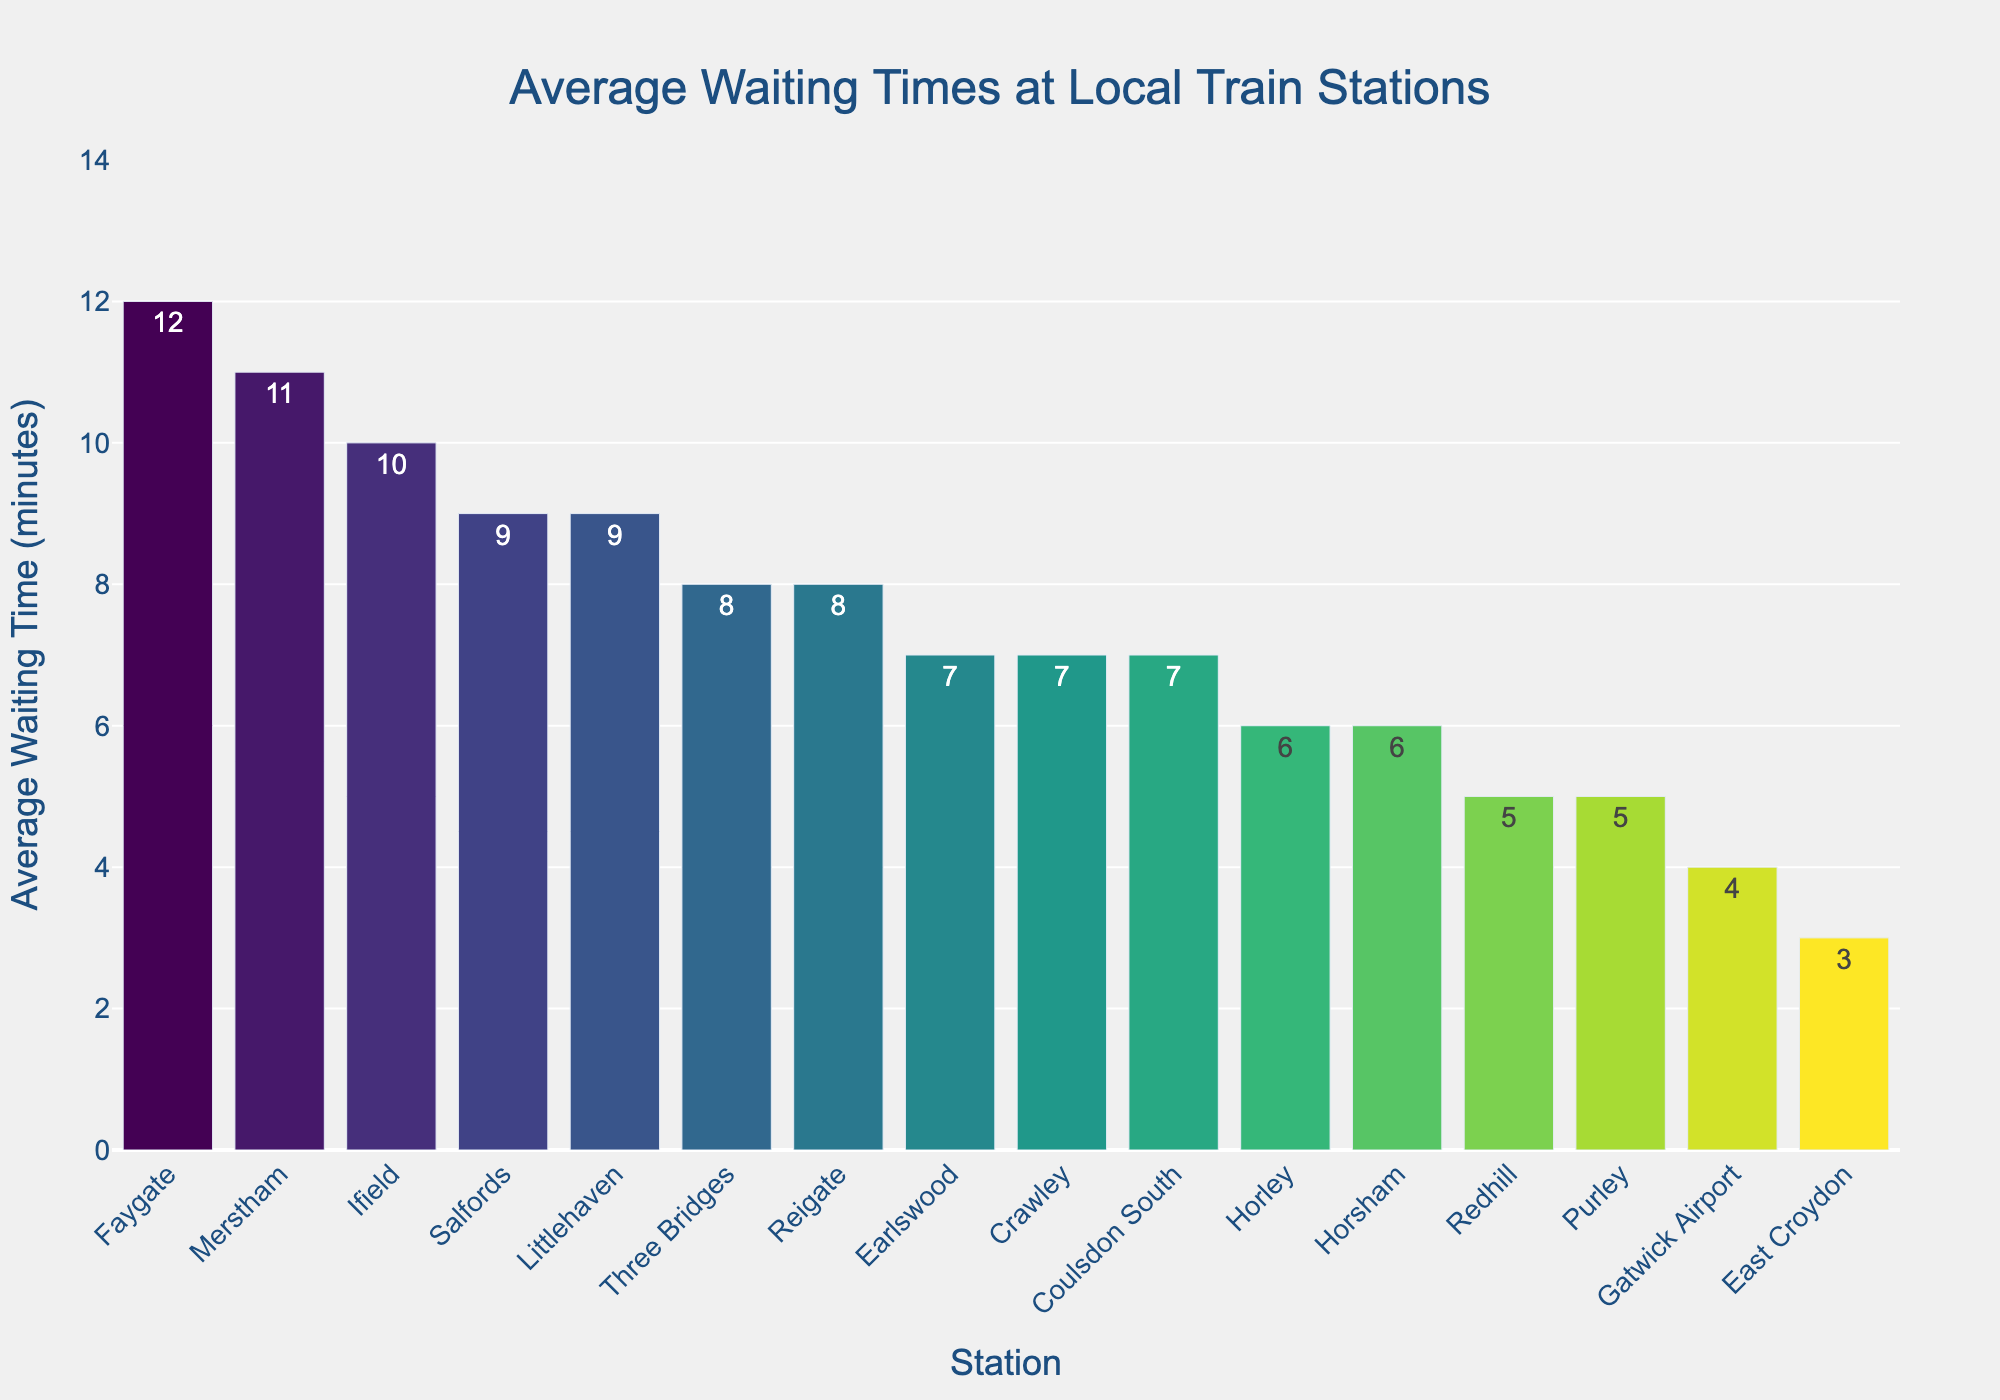Which station has the longest average waiting time? Scan the plot to identify the bar with the tallest height corresponding to the station with the highest wait time.
Answer: Faygate Which stations have an average waiting time greater than 9 minutes? Look for bars exceeding the 9-minute mark on the y-axis and identify the corresponding stations.
Answer: Faygate, Merstham, Ifield, Littlehaven, Salfords What is the average waiting time difference between East Croydon and Ifield? Determine the heights of the bars for East Croydon and Ifield, then subtract the value for East Croydon from Ifield. Calculation: 10 - 3 = 7
Answer: 7 Which station has a shorter waiting time: Redhill or Coulsdon South? Compare the heights of the bars for Redhill and Coulsdon South. The station with the shorter bar has a shorter waiting time.
Answer: Redhill Are there more stations with an average waiting time less than or equal to 6 minutes or more than 9 minutes? Count the number of stations with bars at or below the 6-minute mark and those above the 9-minute mark, then compare the counts.
Answer: Less than or equal to 6 minutes What is the sum of the waiting times for Earlswood, Reigate, and Merstham? Find the individual bar heights for Earlswood, Reigate, and Merstham, then sum those values. Calculation: 7 + 8 + 11 = 26
Answer: 26 Which stations have the same average waiting time of 6 minutes? Identify the bars with a height of 6 minutes and list the corresponding stations.
Answer: Horley, Horsham How much longer is the waiting time at Three Bridges compared to Gatwick Airport? Subtract the waiting time of Gatwick Airport from Three Bridges by comparing their bar heights. Calculation: 8 - 4 = 4
Answer: 4 What is the median average waiting time across all stations? Arrange the waiting times in ascending order and determine the middle value(s). Calculation: The ordered list is [3, 4, 5, 5, 6, 6, 7, 7, 7, 8, 8, 9, 9, 10, 11, 12]. The median is the average of the 8th and 9th values: (7 + 7) / 2 = 7
Answer: 7 